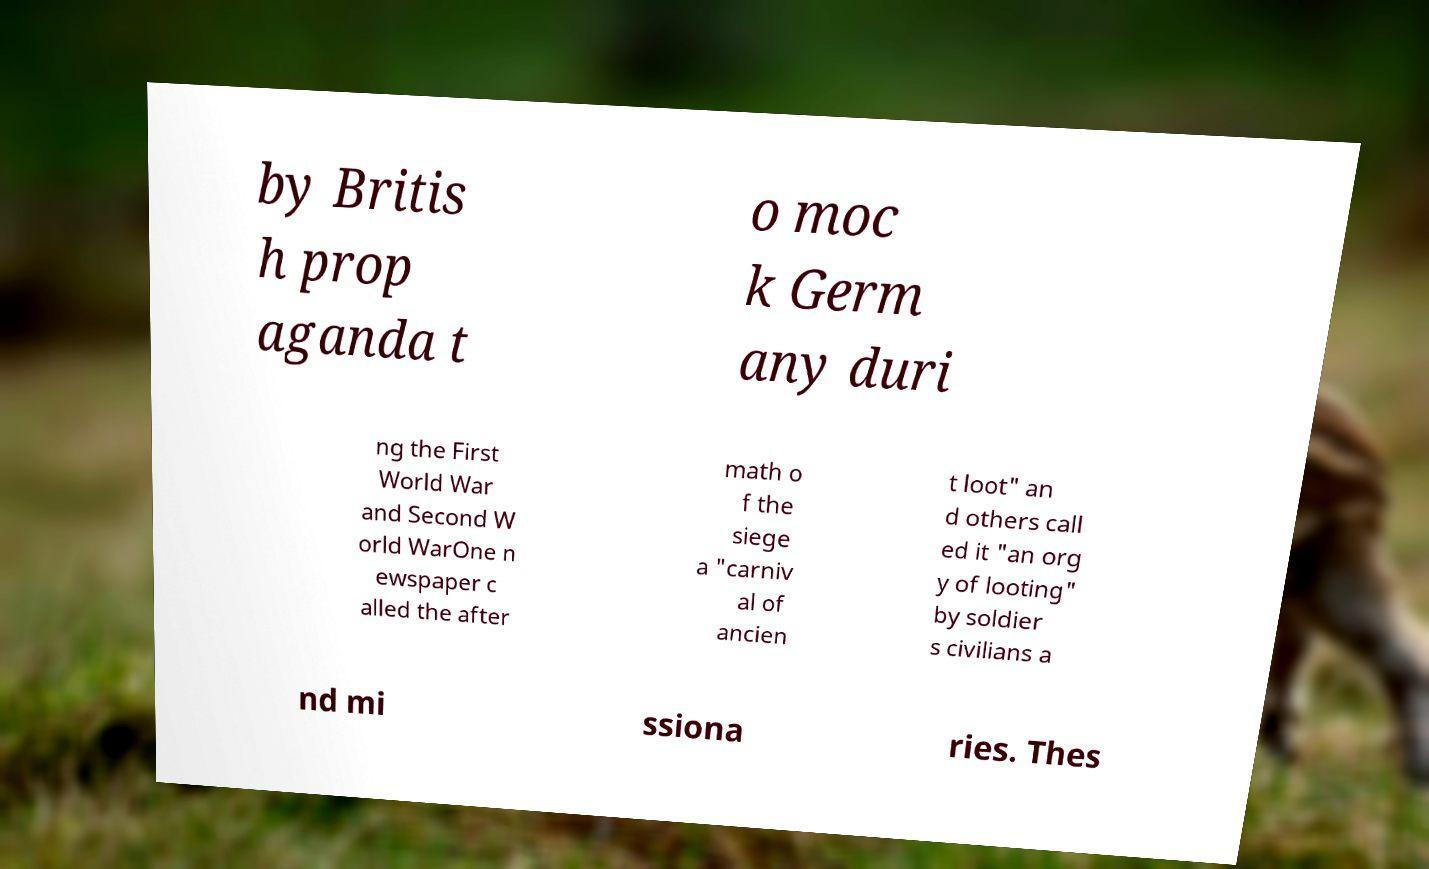For documentation purposes, I need the text within this image transcribed. Could you provide that? by Britis h prop aganda t o moc k Germ any duri ng the First World War and Second W orld WarOne n ewspaper c alled the after math o f the siege a "carniv al of ancien t loot" an d others call ed it "an org y of looting" by soldier s civilians a nd mi ssiona ries. Thes 